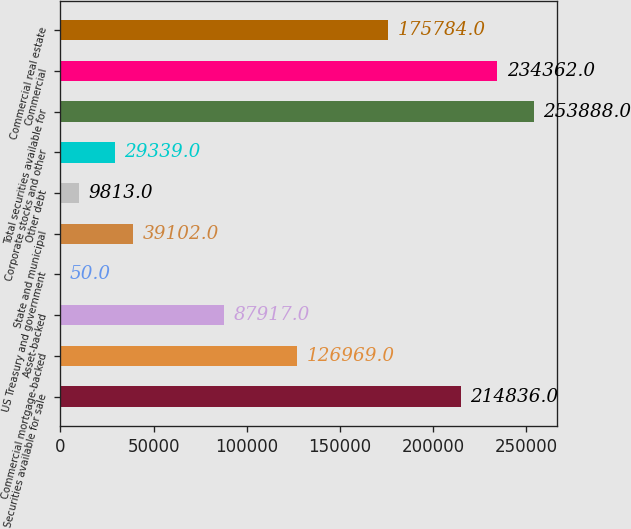<chart> <loc_0><loc_0><loc_500><loc_500><bar_chart><fcel>Securities available for sale<fcel>Commercial mortgage-backed<fcel>Asset-backed<fcel>US Treasury and government<fcel>State and municipal<fcel>Other debt<fcel>Corporate stocks and other<fcel>Total securities available for<fcel>Commercial<fcel>Commercial real estate<nl><fcel>214836<fcel>126969<fcel>87917<fcel>50<fcel>39102<fcel>9813<fcel>29339<fcel>253888<fcel>234362<fcel>175784<nl></chart> 